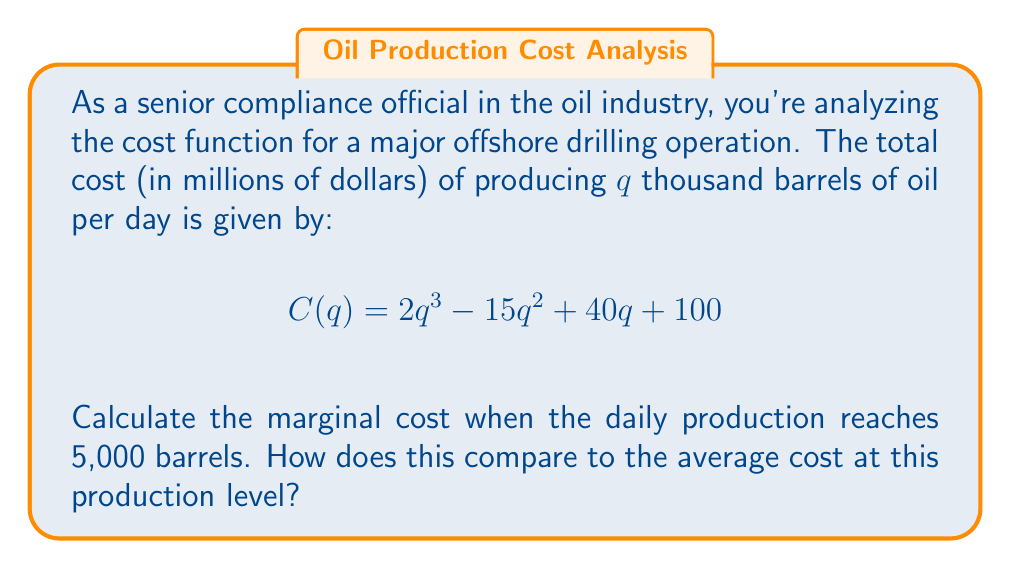Solve this math problem. 1) The marginal cost is the derivative of the total cost function. Let's find $C'(q)$:

   $$C'(q) = 6q^2 - 30q + 40$$

2) To find the marginal cost at 5,000 barrels, we substitute $q = 5$ into $C'(q)$:

   $$C'(5) = 6(5)^2 - 30(5) + 40 = 150 - 150 + 40 = 40$$

3) For the average cost at 5,000 barrels, we need to calculate $C(5)$ and divide by 5:

   $$C(5) = 2(5)^3 - 15(5)^2 + 40(5) + 100 = 250 - 375 + 200 + 100 = 175$$

   Average Cost = $\frac{C(5)}{5} = \frac{175}{5} = 35$

4) Comparing:
   - Marginal Cost at 5,000 barrels: $40 million per thousand barrels
   - Average Cost at 5,000 barrels: $35 million per thousand barrels

The marginal cost is higher than the average cost, indicating increasing costs as production increases.
Answer: Marginal Cost: $40 million per thousand barrels; Higher than Average Cost ($35 million per thousand barrels) 